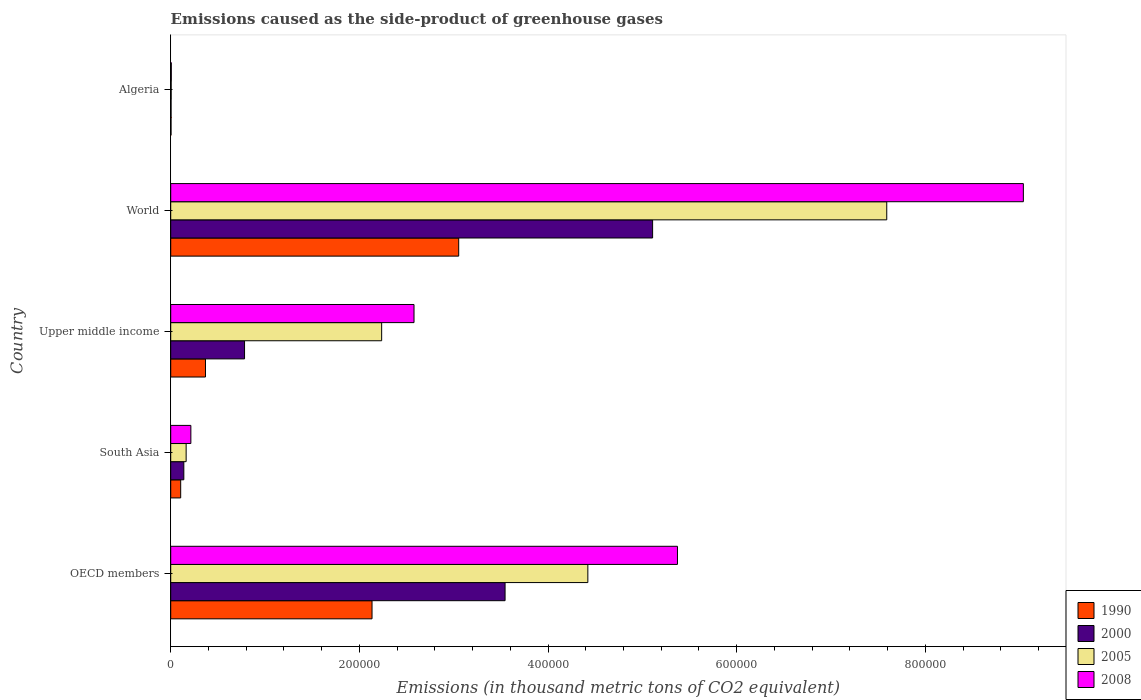How many different coloured bars are there?
Ensure brevity in your answer.  4. How many groups of bars are there?
Give a very brief answer. 5. Are the number of bars per tick equal to the number of legend labels?
Your answer should be compact. Yes. How many bars are there on the 3rd tick from the top?
Provide a short and direct response. 4. How many bars are there on the 2nd tick from the bottom?
Keep it short and to the point. 4. In how many cases, is the number of bars for a given country not equal to the number of legend labels?
Make the answer very short. 0. What is the emissions caused as the side-product of greenhouse gases in 1990 in World?
Keep it short and to the point. 3.05e+05. Across all countries, what is the maximum emissions caused as the side-product of greenhouse gases in 1990?
Offer a very short reply. 3.05e+05. Across all countries, what is the minimum emissions caused as the side-product of greenhouse gases in 2005?
Ensure brevity in your answer.  487.4. In which country was the emissions caused as the side-product of greenhouse gases in 1990 minimum?
Keep it short and to the point. Algeria. What is the total emissions caused as the side-product of greenhouse gases in 2005 in the graph?
Your answer should be very brief. 1.44e+06. What is the difference between the emissions caused as the side-product of greenhouse gases in 2008 in Algeria and that in Upper middle income?
Keep it short and to the point. -2.57e+05. What is the difference between the emissions caused as the side-product of greenhouse gases in 1990 in South Asia and the emissions caused as the side-product of greenhouse gases in 2008 in Upper middle income?
Your answer should be compact. -2.47e+05. What is the average emissions caused as the side-product of greenhouse gases in 1990 per country?
Offer a very short reply. 1.13e+05. What is the difference between the emissions caused as the side-product of greenhouse gases in 2000 and emissions caused as the side-product of greenhouse gases in 2008 in South Asia?
Offer a very short reply. -7460.6. In how many countries, is the emissions caused as the side-product of greenhouse gases in 2000 greater than 840000 thousand metric tons?
Offer a very short reply. 0. What is the ratio of the emissions caused as the side-product of greenhouse gases in 2000 in South Asia to that in Upper middle income?
Your answer should be very brief. 0.18. Is the difference between the emissions caused as the side-product of greenhouse gases in 2000 in OECD members and World greater than the difference between the emissions caused as the side-product of greenhouse gases in 2008 in OECD members and World?
Your answer should be very brief. Yes. What is the difference between the highest and the second highest emissions caused as the side-product of greenhouse gases in 2000?
Your answer should be very brief. 1.56e+05. What is the difference between the highest and the lowest emissions caused as the side-product of greenhouse gases in 2000?
Your answer should be compact. 5.11e+05. What does the 2nd bar from the bottom in South Asia represents?
Offer a terse response. 2000. Is it the case that in every country, the sum of the emissions caused as the side-product of greenhouse gases in 1990 and emissions caused as the side-product of greenhouse gases in 2005 is greater than the emissions caused as the side-product of greenhouse gases in 2000?
Make the answer very short. Yes. How many bars are there?
Provide a succinct answer. 20. How many countries are there in the graph?
Offer a very short reply. 5. What is the difference between two consecutive major ticks on the X-axis?
Offer a very short reply. 2.00e+05. Are the values on the major ticks of X-axis written in scientific E-notation?
Provide a succinct answer. No. Does the graph contain grids?
Provide a short and direct response. No. Where does the legend appear in the graph?
Your response must be concise. Bottom right. What is the title of the graph?
Your answer should be very brief. Emissions caused as the side-product of greenhouse gases. Does "1968" appear as one of the legend labels in the graph?
Offer a very short reply. No. What is the label or title of the X-axis?
Offer a terse response. Emissions (in thousand metric tons of CO2 equivalent). What is the Emissions (in thousand metric tons of CO2 equivalent) in 1990 in OECD members?
Ensure brevity in your answer.  2.13e+05. What is the Emissions (in thousand metric tons of CO2 equivalent) of 2000 in OECD members?
Your response must be concise. 3.54e+05. What is the Emissions (in thousand metric tons of CO2 equivalent) of 2005 in OECD members?
Your answer should be compact. 4.42e+05. What is the Emissions (in thousand metric tons of CO2 equivalent) in 2008 in OECD members?
Your response must be concise. 5.37e+05. What is the Emissions (in thousand metric tons of CO2 equivalent) of 1990 in South Asia?
Your answer should be compact. 1.06e+04. What is the Emissions (in thousand metric tons of CO2 equivalent) of 2000 in South Asia?
Provide a short and direct response. 1.39e+04. What is the Emissions (in thousand metric tons of CO2 equivalent) in 2005 in South Asia?
Give a very brief answer. 1.64e+04. What is the Emissions (in thousand metric tons of CO2 equivalent) of 2008 in South Asia?
Make the answer very short. 2.14e+04. What is the Emissions (in thousand metric tons of CO2 equivalent) in 1990 in Upper middle income?
Ensure brevity in your answer.  3.69e+04. What is the Emissions (in thousand metric tons of CO2 equivalent) in 2000 in Upper middle income?
Your answer should be very brief. 7.83e+04. What is the Emissions (in thousand metric tons of CO2 equivalent) in 2005 in Upper middle income?
Your answer should be compact. 2.24e+05. What is the Emissions (in thousand metric tons of CO2 equivalent) of 2008 in Upper middle income?
Ensure brevity in your answer.  2.58e+05. What is the Emissions (in thousand metric tons of CO2 equivalent) in 1990 in World?
Ensure brevity in your answer.  3.05e+05. What is the Emissions (in thousand metric tons of CO2 equivalent) in 2000 in World?
Make the answer very short. 5.11e+05. What is the Emissions (in thousand metric tons of CO2 equivalent) of 2005 in World?
Provide a short and direct response. 7.59e+05. What is the Emissions (in thousand metric tons of CO2 equivalent) in 2008 in World?
Ensure brevity in your answer.  9.04e+05. What is the Emissions (in thousand metric tons of CO2 equivalent) of 1990 in Algeria?
Your answer should be compact. 326. What is the Emissions (in thousand metric tons of CO2 equivalent) of 2000 in Algeria?
Offer a very short reply. 371.9. What is the Emissions (in thousand metric tons of CO2 equivalent) of 2005 in Algeria?
Your answer should be compact. 487.4. What is the Emissions (in thousand metric tons of CO2 equivalent) of 2008 in Algeria?
Your answer should be compact. 613.9. Across all countries, what is the maximum Emissions (in thousand metric tons of CO2 equivalent) of 1990?
Offer a terse response. 3.05e+05. Across all countries, what is the maximum Emissions (in thousand metric tons of CO2 equivalent) of 2000?
Give a very brief answer. 5.11e+05. Across all countries, what is the maximum Emissions (in thousand metric tons of CO2 equivalent) in 2005?
Make the answer very short. 7.59e+05. Across all countries, what is the maximum Emissions (in thousand metric tons of CO2 equivalent) in 2008?
Ensure brevity in your answer.  9.04e+05. Across all countries, what is the minimum Emissions (in thousand metric tons of CO2 equivalent) in 1990?
Your response must be concise. 326. Across all countries, what is the minimum Emissions (in thousand metric tons of CO2 equivalent) of 2000?
Give a very brief answer. 371.9. Across all countries, what is the minimum Emissions (in thousand metric tons of CO2 equivalent) in 2005?
Keep it short and to the point. 487.4. Across all countries, what is the minimum Emissions (in thousand metric tons of CO2 equivalent) in 2008?
Make the answer very short. 613.9. What is the total Emissions (in thousand metric tons of CO2 equivalent) in 1990 in the graph?
Your answer should be very brief. 5.67e+05. What is the total Emissions (in thousand metric tons of CO2 equivalent) of 2000 in the graph?
Make the answer very short. 9.58e+05. What is the total Emissions (in thousand metric tons of CO2 equivalent) of 2005 in the graph?
Offer a terse response. 1.44e+06. What is the total Emissions (in thousand metric tons of CO2 equivalent) in 2008 in the graph?
Your answer should be very brief. 1.72e+06. What is the difference between the Emissions (in thousand metric tons of CO2 equivalent) in 1990 in OECD members and that in South Asia?
Provide a succinct answer. 2.03e+05. What is the difference between the Emissions (in thousand metric tons of CO2 equivalent) of 2000 in OECD members and that in South Asia?
Give a very brief answer. 3.41e+05. What is the difference between the Emissions (in thousand metric tons of CO2 equivalent) of 2005 in OECD members and that in South Asia?
Give a very brief answer. 4.26e+05. What is the difference between the Emissions (in thousand metric tons of CO2 equivalent) in 2008 in OECD members and that in South Asia?
Keep it short and to the point. 5.16e+05. What is the difference between the Emissions (in thousand metric tons of CO2 equivalent) in 1990 in OECD members and that in Upper middle income?
Offer a terse response. 1.77e+05. What is the difference between the Emissions (in thousand metric tons of CO2 equivalent) of 2000 in OECD members and that in Upper middle income?
Your answer should be compact. 2.76e+05. What is the difference between the Emissions (in thousand metric tons of CO2 equivalent) in 2005 in OECD members and that in Upper middle income?
Offer a very short reply. 2.19e+05. What is the difference between the Emissions (in thousand metric tons of CO2 equivalent) of 2008 in OECD members and that in Upper middle income?
Ensure brevity in your answer.  2.79e+05. What is the difference between the Emissions (in thousand metric tons of CO2 equivalent) of 1990 in OECD members and that in World?
Give a very brief answer. -9.19e+04. What is the difference between the Emissions (in thousand metric tons of CO2 equivalent) of 2000 in OECD members and that in World?
Your answer should be very brief. -1.56e+05. What is the difference between the Emissions (in thousand metric tons of CO2 equivalent) of 2005 in OECD members and that in World?
Provide a succinct answer. -3.17e+05. What is the difference between the Emissions (in thousand metric tons of CO2 equivalent) of 2008 in OECD members and that in World?
Offer a very short reply. -3.67e+05. What is the difference between the Emissions (in thousand metric tons of CO2 equivalent) in 1990 in OECD members and that in Algeria?
Your answer should be very brief. 2.13e+05. What is the difference between the Emissions (in thousand metric tons of CO2 equivalent) in 2000 in OECD members and that in Algeria?
Offer a terse response. 3.54e+05. What is the difference between the Emissions (in thousand metric tons of CO2 equivalent) in 2005 in OECD members and that in Algeria?
Your response must be concise. 4.42e+05. What is the difference between the Emissions (in thousand metric tons of CO2 equivalent) in 2008 in OECD members and that in Algeria?
Give a very brief answer. 5.37e+05. What is the difference between the Emissions (in thousand metric tons of CO2 equivalent) of 1990 in South Asia and that in Upper middle income?
Provide a succinct answer. -2.63e+04. What is the difference between the Emissions (in thousand metric tons of CO2 equivalent) in 2000 in South Asia and that in Upper middle income?
Offer a terse response. -6.44e+04. What is the difference between the Emissions (in thousand metric tons of CO2 equivalent) of 2005 in South Asia and that in Upper middle income?
Keep it short and to the point. -2.07e+05. What is the difference between the Emissions (in thousand metric tons of CO2 equivalent) in 2008 in South Asia and that in Upper middle income?
Ensure brevity in your answer.  -2.37e+05. What is the difference between the Emissions (in thousand metric tons of CO2 equivalent) in 1990 in South Asia and that in World?
Make the answer very short. -2.95e+05. What is the difference between the Emissions (in thousand metric tons of CO2 equivalent) in 2000 in South Asia and that in World?
Your answer should be compact. -4.97e+05. What is the difference between the Emissions (in thousand metric tons of CO2 equivalent) of 2005 in South Asia and that in World?
Offer a terse response. -7.43e+05. What is the difference between the Emissions (in thousand metric tons of CO2 equivalent) in 2008 in South Asia and that in World?
Give a very brief answer. -8.83e+05. What is the difference between the Emissions (in thousand metric tons of CO2 equivalent) of 1990 in South Asia and that in Algeria?
Offer a terse response. 1.02e+04. What is the difference between the Emissions (in thousand metric tons of CO2 equivalent) in 2000 in South Asia and that in Algeria?
Offer a terse response. 1.35e+04. What is the difference between the Emissions (in thousand metric tons of CO2 equivalent) of 2005 in South Asia and that in Algeria?
Ensure brevity in your answer.  1.59e+04. What is the difference between the Emissions (in thousand metric tons of CO2 equivalent) in 2008 in South Asia and that in Algeria?
Give a very brief answer. 2.07e+04. What is the difference between the Emissions (in thousand metric tons of CO2 equivalent) of 1990 in Upper middle income and that in World?
Your response must be concise. -2.68e+05. What is the difference between the Emissions (in thousand metric tons of CO2 equivalent) of 2000 in Upper middle income and that in World?
Offer a terse response. -4.33e+05. What is the difference between the Emissions (in thousand metric tons of CO2 equivalent) of 2005 in Upper middle income and that in World?
Provide a short and direct response. -5.36e+05. What is the difference between the Emissions (in thousand metric tons of CO2 equivalent) of 2008 in Upper middle income and that in World?
Give a very brief answer. -6.46e+05. What is the difference between the Emissions (in thousand metric tons of CO2 equivalent) in 1990 in Upper middle income and that in Algeria?
Provide a short and direct response. 3.65e+04. What is the difference between the Emissions (in thousand metric tons of CO2 equivalent) of 2000 in Upper middle income and that in Algeria?
Ensure brevity in your answer.  7.79e+04. What is the difference between the Emissions (in thousand metric tons of CO2 equivalent) of 2005 in Upper middle income and that in Algeria?
Provide a succinct answer. 2.23e+05. What is the difference between the Emissions (in thousand metric tons of CO2 equivalent) in 2008 in Upper middle income and that in Algeria?
Provide a short and direct response. 2.57e+05. What is the difference between the Emissions (in thousand metric tons of CO2 equivalent) of 1990 in World and that in Algeria?
Give a very brief answer. 3.05e+05. What is the difference between the Emissions (in thousand metric tons of CO2 equivalent) in 2000 in World and that in Algeria?
Provide a succinct answer. 5.11e+05. What is the difference between the Emissions (in thousand metric tons of CO2 equivalent) of 2005 in World and that in Algeria?
Ensure brevity in your answer.  7.59e+05. What is the difference between the Emissions (in thousand metric tons of CO2 equivalent) in 2008 in World and that in Algeria?
Give a very brief answer. 9.03e+05. What is the difference between the Emissions (in thousand metric tons of CO2 equivalent) in 1990 in OECD members and the Emissions (in thousand metric tons of CO2 equivalent) in 2000 in South Asia?
Offer a very short reply. 2.00e+05. What is the difference between the Emissions (in thousand metric tons of CO2 equivalent) of 1990 in OECD members and the Emissions (in thousand metric tons of CO2 equivalent) of 2005 in South Asia?
Offer a very short reply. 1.97e+05. What is the difference between the Emissions (in thousand metric tons of CO2 equivalent) of 1990 in OECD members and the Emissions (in thousand metric tons of CO2 equivalent) of 2008 in South Asia?
Offer a very short reply. 1.92e+05. What is the difference between the Emissions (in thousand metric tons of CO2 equivalent) of 2000 in OECD members and the Emissions (in thousand metric tons of CO2 equivalent) of 2005 in South Asia?
Provide a short and direct response. 3.38e+05. What is the difference between the Emissions (in thousand metric tons of CO2 equivalent) of 2000 in OECD members and the Emissions (in thousand metric tons of CO2 equivalent) of 2008 in South Asia?
Your response must be concise. 3.33e+05. What is the difference between the Emissions (in thousand metric tons of CO2 equivalent) of 2005 in OECD members and the Emissions (in thousand metric tons of CO2 equivalent) of 2008 in South Asia?
Ensure brevity in your answer.  4.21e+05. What is the difference between the Emissions (in thousand metric tons of CO2 equivalent) of 1990 in OECD members and the Emissions (in thousand metric tons of CO2 equivalent) of 2000 in Upper middle income?
Keep it short and to the point. 1.35e+05. What is the difference between the Emissions (in thousand metric tons of CO2 equivalent) in 1990 in OECD members and the Emissions (in thousand metric tons of CO2 equivalent) in 2005 in Upper middle income?
Make the answer very short. -1.02e+04. What is the difference between the Emissions (in thousand metric tons of CO2 equivalent) of 1990 in OECD members and the Emissions (in thousand metric tons of CO2 equivalent) of 2008 in Upper middle income?
Your answer should be very brief. -4.45e+04. What is the difference between the Emissions (in thousand metric tons of CO2 equivalent) of 2000 in OECD members and the Emissions (in thousand metric tons of CO2 equivalent) of 2005 in Upper middle income?
Your answer should be very brief. 1.31e+05. What is the difference between the Emissions (in thousand metric tons of CO2 equivalent) in 2000 in OECD members and the Emissions (in thousand metric tons of CO2 equivalent) in 2008 in Upper middle income?
Provide a succinct answer. 9.65e+04. What is the difference between the Emissions (in thousand metric tons of CO2 equivalent) of 2005 in OECD members and the Emissions (in thousand metric tons of CO2 equivalent) of 2008 in Upper middle income?
Your answer should be very brief. 1.84e+05. What is the difference between the Emissions (in thousand metric tons of CO2 equivalent) in 1990 in OECD members and the Emissions (in thousand metric tons of CO2 equivalent) in 2000 in World?
Keep it short and to the point. -2.97e+05. What is the difference between the Emissions (in thousand metric tons of CO2 equivalent) in 1990 in OECD members and the Emissions (in thousand metric tons of CO2 equivalent) in 2005 in World?
Make the answer very short. -5.46e+05. What is the difference between the Emissions (in thousand metric tons of CO2 equivalent) of 1990 in OECD members and the Emissions (in thousand metric tons of CO2 equivalent) of 2008 in World?
Make the answer very short. -6.91e+05. What is the difference between the Emissions (in thousand metric tons of CO2 equivalent) of 2000 in OECD members and the Emissions (in thousand metric tons of CO2 equivalent) of 2005 in World?
Your answer should be very brief. -4.05e+05. What is the difference between the Emissions (in thousand metric tons of CO2 equivalent) of 2000 in OECD members and the Emissions (in thousand metric tons of CO2 equivalent) of 2008 in World?
Your answer should be compact. -5.49e+05. What is the difference between the Emissions (in thousand metric tons of CO2 equivalent) in 2005 in OECD members and the Emissions (in thousand metric tons of CO2 equivalent) in 2008 in World?
Offer a very short reply. -4.62e+05. What is the difference between the Emissions (in thousand metric tons of CO2 equivalent) in 1990 in OECD members and the Emissions (in thousand metric tons of CO2 equivalent) in 2000 in Algeria?
Offer a very short reply. 2.13e+05. What is the difference between the Emissions (in thousand metric tons of CO2 equivalent) of 1990 in OECD members and the Emissions (in thousand metric tons of CO2 equivalent) of 2005 in Algeria?
Give a very brief answer. 2.13e+05. What is the difference between the Emissions (in thousand metric tons of CO2 equivalent) of 1990 in OECD members and the Emissions (in thousand metric tons of CO2 equivalent) of 2008 in Algeria?
Keep it short and to the point. 2.13e+05. What is the difference between the Emissions (in thousand metric tons of CO2 equivalent) of 2000 in OECD members and the Emissions (in thousand metric tons of CO2 equivalent) of 2005 in Algeria?
Provide a short and direct response. 3.54e+05. What is the difference between the Emissions (in thousand metric tons of CO2 equivalent) of 2000 in OECD members and the Emissions (in thousand metric tons of CO2 equivalent) of 2008 in Algeria?
Make the answer very short. 3.54e+05. What is the difference between the Emissions (in thousand metric tons of CO2 equivalent) in 2005 in OECD members and the Emissions (in thousand metric tons of CO2 equivalent) in 2008 in Algeria?
Keep it short and to the point. 4.42e+05. What is the difference between the Emissions (in thousand metric tons of CO2 equivalent) in 1990 in South Asia and the Emissions (in thousand metric tons of CO2 equivalent) in 2000 in Upper middle income?
Provide a short and direct response. -6.77e+04. What is the difference between the Emissions (in thousand metric tons of CO2 equivalent) in 1990 in South Asia and the Emissions (in thousand metric tons of CO2 equivalent) in 2005 in Upper middle income?
Offer a terse response. -2.13e+05. What is the difference between the Emissions (in thousand metric tons of CO2 equivalent) in 1990 in South Asia and the Emissions (in thousand metric tons of CO2 equivalent) in 2008 in Upper middle income?
Offer a very short reply. -2.47e+05. What is the difference between the Emissions (in thousand metric tons of CO2 equivalent) in 2000 in South Asia and the Emissions (in thousand metric tons of CO2 equivalent) in 2005 in Upper middle income?
Provide a succinct answer. -2.10e+05. What is the difference between the Emissions (in thousand metric tons of CO2 equivalent) in 2000 in South Asia and the Emissions (in thousand metric tons of CO2 equivalent) in 2008 in Upper middle income?
Offer a terse response. -2.44e+05. What is the difference between the Emissions (in thousand metric tons of CO2 equivalent) of 2005 in South Asia and the Emissions (in thousand metric tons of CO2 equivalent) of 2008 in Upper middle income?
Your response must be concise. -2.42e+05. What is the difference between the Emissions (in thousand metric tons of CO2 equivalent) in 1990 in South Asia and the Emissions (in thousand metric tons of CO2 equivalent) in 2000 in World?
Keep it short and to the point. -5.00e+05. What is the difference between the Emissions (in thousand metric tons of CO2 equivalent) of 1990 in South Asia and the Emissions (in thousand metric tons of CO2 equivalent) of 2005 in World?
Offer a very short reply. -7.49e+05. What is the difference between the Emissions (in thousand metric tons of CO2 equivalent) in 1990 in South Asia and the Emissions (in thousand metric tons of CO2 equivalent) in 2008 in World?
Offer a very short reply. -8.93e+05. What is the difference between the Emissions (in thousand metric tons of CO2 equivalent) of 2000 in South Asia and the Emissions (in thousand metric tons of CO2 equivalent) of 2005 in World?
Offer a very short reply. -7.45e+05. What is the difference between the Emissions (in thousand metric tons of CO2 equivalent) in 2000 in South Asia and the Emissions (in thousand metric tons of CO2 equivalent) in 2008 in World?
Offer a very short reply. -8.90e+05. What is the difference between the Emissions (in thousand metric tons of CO2 equivalent) of 2005 in South Asia and the Emissions (in thousand metric tons of CO2 equivalent) of 2008 in World?
Ensure brevity in your answer.  -8.88e+05. What is the difference between the Emissions (in thousand metric tons of CO2 equivalent) of 1990 in South Asia and the Emissions (in thousand metric tons of CO2 equivalent) of 2000 in Algeria?
Offer a very short reply. 1.02e+04. What is the difference between the Emissions (in thousand metric tons of CO2 equivalent) in 1990 in South Asia and the Emissions (in thousand metric tons of CO2 equivalent) in 2005 in Algeria?
Give a very brief answer. 1.01e+04. What is the difference between the Emissions (in thousand metric tons of CO2 equivalent) of 1990 in South Asia and the Emissions (in thousand metric tons of CO2 equivalent) of 2008 in Algeria?
Offer a very short reply. 9958.7. What is the difference between the Emissions (in thousand metric tons of CO2 equivalent) in 2000 in South Asia and the Emissions (in thousand metric tons of CO2 equivalent) in 2005 in Algeria?
Offer a terse response. 1.34e+04. What is the difference between the Emissions (in thousand metric tons of CO2 equivalent) of 2000 in South Asia and the Emissions (in thousand metric tons of CO2 equivalent) of 2008 in Algeria?
Provide a succinct answer. 1.33e+04. What is the difference between the Emissions (in thousand metric tons of CO2 equivalent) in 2005 in South Asia and the Emissions (in thousand metric tons of CO2 equivalent) in 2008 in Algeria?
Provide a succinct answer. 1.57e+04. What is the difference between the Emissions (in thousand metric tons of CO2 equivalent) of 1990 in Upper middle income and the Emissions (in thousand metric tons of CO2 equivalent) of 2000 in World?
Provide a succinct answer. -4.74e+05. What is the difference between the Emissions (in thousand metric tons of CO2 equivalent) of 1990 in Upper middle income and the Emissions (in thousand metric tons of CO2 equivalent) of 2005 in World?
Give a very brief answer. -7.22e+05. What is the difference between the Emissions (in thousand metric tons of CO2 equivalent) in 1990 in Upper middle income and the Emissions (in thousand metric tons of CO2 equivalent) in 2008 in World?
Keep it short and to the point. -8.67e+05. What is the difference between the Emissions (in thousand metric tons of CO2 equivalent) in 2000 in Upper middle income and the Emissions (in thousand metric tons of CO2 equivalent) in 2005 in World?
Give a very brief answer. -6.81e+05. What is the difference between the Emissions (in thousand metric tons of CO2 equivalent) of 2000 in Upper middle income and the Emissions (in thousand metric tons of CO2 equivalent) of 2008 in World?
Your answer should be compact. -8.26e+05. What is the difference between the Emissions (in thousand metric tons of CO2 equivalent) in 2005 in Upper middle income and the Emissions (in thousand metric tons of CO2 equivalent) in 2008 in World?
Offer a very short reply. -6.80e+05. What is the difference between the Emissions (in thousand metric tons of CO2 equivalent) in 1990 in Upper middle income and the Emissions (in thousand metric tons of CO2 equivalent) in 2000 in Algeria?
Provide a succinct answer. 3.65e+04. What is the difference between the Emissions (in thousand metric tons of CO2 equivalent) of 1990 in Upper middle income and the Emissions (in thousand metric tons of CO2 equivalent) of 2005 in Algeria?
Ensure brevity in your answer.  3.64e+04. What is the difference between the Emissions (in thousand metric tons of CO2 equivalent) of 1990 in Upper middle income and the Emissions (in thousand metric tons of CO2 equivalent) of 2008 in Algeria?
Your answer should be compact. 3.63e+04. What is the difference between the Emissions (in thousand metric tons of CO2 equivalent) of 2000 in Upper middle income and the Emissions (in thousand metric tons of CO2 equivalent) of 2005 in Algeria?
Your response must be concise. 7.78e+04. What is the difference between the Emissions (in thousand metric tons of CO2 equivalent) of 2000 in Upper middle income and the Emissions (in thousand metric tons of CO2 equivalent) of 2008 in Algeria?
Provide a succinct answer. 7.77e+04. What is the difference between the Emissions (in thousand metric tons of CO2 equivalent) in 2005 in Upper middle income and the Emissions (in thousand metric tons of CO2 equivalent) in 2008 in Algeria?
Your answer should be compact. 2.23e+05. What is the difference between the Emissions (in thousand metric tons of CO2 equivalent) in 1990 in World and the Emissions (in thousand metric tons of CO2 equivalent) in 2000 in Algeria?
Provide a succinct answer. 3.05e+05. What is the difference between the Emissions (in thousand metric tons of CO2 equivalent) in 1990 in World and the Emissions (in thousand metric tons of CO2 equivalent) in 2005 in Algeria?
Your answer should be compact. 3.05e+05. What is the difference between the Emissions (in thousand metric tons of CO2 equivalent) of 1990 in World and the Emissions (in thousand metric tons of CO2 equivalent) of 2008 in Algeria?
Make the answer very short. 3.05e+05. What is the difference between the Emissions (in thousand metric tons of CO2 equivalent) in 2000 in World and the Emissions (in thousand metric tons of CO2 equivalent) in 2005 in Algeria?
Ensure brevity in your answer.  5.10e+05. What is the difference between the Emissions (in thousand metric tons of CO2 equivalent) of 2000 in World and the Emissions (in thousand metric tons of CO2 equivalent) of 2008 in Algeria?
Give a very brief answer. 5.10e+05. What is the difference between the Emissions (in thousand metric tons of CO2 equivalent) in 2005 in World and the Emissions (in thousand metric tons of CO2 equivalent) in 2008 in Algeria?
Make the answer very short. 7.59e+05. What is the average Emissions (in thousand metric tons of CO2 equivalent) of 1990 per country?
Provide a short and direct response. 1.13e+05. What is the average Emissions (in thousand metric tons of CO2 equivalent) of 2000 per country?
Provide a short and direct response. 1.92e+05. What is the average Emissions (in thousand metric tons of CO2 equivalent) of 2005 per country?
Offer a terse response. 2.88e+05. What is the average Emissions (in thousand metric tons of CO2 equivalent) of 2008 per country?
Provide a short and direct response. 3.44e+05. What is the difference between the Emissions (in thousand metric tons of CO2 equivalent) of 1990 and Emissions (in thousand metric tons of CO2 equivalent) of 2000 in OECD members?
Offer a terse response. -1.41e+05. What is the difference between the Emissions (in thousand metric tons of CO2 equivalent) of 1990 and Emissions (in thousand metric tons of CO2 equivalent) of 2005 in OECD members?
Provide a short and direct response. -2.29e+05. What is the difference between the Emissions (in thousand metric tons of CO2 equivalent) in 1990 and Emissions (in thousand metric tons of CO2 equivalent) in 2008 in OECD members?
Make the answer very short. -3.24e+05. What is the difference between the Emissions (in thousand metric tons of CO2 equivalent) in 2000 and Emissions (in thousand metric tons of CO2 equivalent) in 2005 in OECD members?
Your response must be concise. -8.78e+04. What is the difference between the Emissions (in thousand metric tons of CO2 equivalent) in 2000 and Emissions (in thousand metric tons of CO2 equivalent) in 2008 in OECD members?
Your answer should be compact. -1.83e+05. What is the difference between the Emissions (in thousand metric tons of CO2 equivalent) in 2005 and Emissions (in thousand metric tons of CO2 equivalent) in 2008 in OECD members?
Ensure brevity in your answer.  -9.50e+04. What is the difference between the Emissions (in thousand metric tons of CO2 equivalent) of 1990 and Emissions (in thousand metric tons of CO2 equivalent) of 2000 in South Asia?
Offer a terse response. -3325.3. What is the difference between the Emissions (in thousand metric tons of CO2 equivalent) in 1990 and Emissions (in thousand metric tons of CO2 equivalent) in 2005 in South Asia?
Offer a terse response. -5786.5. What is the difference between the Emissions (in thousand metric tons of CO2 equivalent) in 1990 and Emissions (in thousand metric tons of CO2 equivalent) in 2008 in South Asia?
Your response must be concise. -1.08e+04. What is the difference between the Emissions (in thousand metric tons of CO2 equivalent) in 2000 and Emissions (in thousand metric tons of CO2 equivalent) in 2005 in South Asia?
Offer a terse response. -2461.2. What is the difference between the Emissions (in thousand metric tons of CO2 equivalent) of 2000 and Emissions (in thousand metric tons of CO2 equivalent) of 2008 in South Asia?
Give a very brief answer. -7460.6. What is the difference between the Emissions (in thousand metric tons of CO2 equivalent) in 2005 and Emissions (in thousand metric tons of CO2 equivalent) in 2008 in South Asia?
Offer a very short reply. -4999.4. What is the difference between the Emissions (in thousand metric tons of CO2 equivalent) in 1990 and Emissions (in thousand metric tons of CO2 equivalent) in 2000 in Upper middle income?
Provide a short and direct response. -4.14e+04. What is the difference between the Emissions (in thousand metric tons of CO2 equivalent) in 1990 and Emissions (in thousand metric tons of CO2 equivalent) in 2005 in Upper middle income?
Offer a terse response. -1.87e+05. What is the difference between the Emissions (in thousand metric tons of CO2 equivalent) of 1990 and Emissions (in thousand metric tons of CO2 equivalent) of 2008 in Upper middle income?
Provide a short and direct response. -2.21e+05. What is the difference between the Emissions (in thousand metric tons of CO2 equivalent) of 2000 and Emissions (in thousand metric tons of CO2 equivalent) of 2005 in Upper middle income?
Offer a terse response. -1.45e+05. What is the difference between the Emissions (in thousand metric tons of CO2 equivalent) in 2000 and Emissions (in thousand metric tons of CO2 equivalent) in 2008 in Upper middle income?
Keep it short and to the point. -1.80e+05. What is the difference between the Emissions (in thousand metric tons of CO2 equivalent) in 2005 and Emissions (in thousand metric tons of CO2 equivalent) in 2008 in Upper middle income?
Offer a terse response. -3.43e+04. What is the difference between the Emissions (in thousand metric tons of CO2 equivalent) in 1990 and Emissions (in thousand metric tons of CO2 equivalent) in 2000 in World?
Keep it short and to the point. -2.06e+05. What is the difference between the Emissions (in thousand metric tons of CO2 equivalent) in 1990 and Emissions (in thousand metric tons of CO2 equivalent) in 2005 in World?
Provide a short and direct response. -4.54e+05. What is the difference between the Emissions (in thousand metric tons of CO2 equivalent) in 1990 and Emissions (in thousand metric tons of CO2 equivalent) in 2008 in World?
Provide a succinct answer. -5.99e+05. What is the difference between the Emissions (in thousand metric tons of CO2 equivalent) in 2000 and Emissions (in thousand metric tons of CO2 equivalent) in 2005 in World?
Your response must be concise. -2.48e+05. What is the difference between the Emissions (in thousand metric tons of CO2 equivalent) in 2000 and Emissions (in thousand metric tons of CO2 equivalent) in 2008 in World?
Offer a terse response. -3.93e+05. What is the difference between the Emissions (in thousand metric tons of CO2 equivalent) in 2005 and Emissions (in thousand metric tons of CO2 equivalent) in 2008 in World?
Your answer should be very brief. -1.45e+05. What is the difference between the Emissions (in thousand metric tons of CO2 equivalent) of 1990 and Emissions (in thousand metric tons of CO2 equivalent) of 2000 in Algeria?
Keep it short and to the point. -45.9. What is the difference between the Emissions (in thousand metric tons of CO2 equivalent) in 1990 and Emissions (in thousand metric tons of CO2 equivalent) in 2005 in Algeria?
Keep it short and to the point. -161.4. What is the difference between the Emissions (in thousand metric tons of CO2 equivalent) in 1990 and Emissions (in thousand metric tons of CO2 equivalent) in 2008 in Algeria?
Keep it short and to the point. -287.9. What is the difference between the Emissions (in thousand metric tons of CO2 equivalent) in 2000 and Emissions (in thousand metric tons of CO2 equivalent) in 2005 in Algeria?
Provide a short and direct response. -115.5. What is the difference between the Emissions (in thousand metric tons of CO2 equivalent) in 2000 and Emissions (in thousand metric tons of CO2 equivalent) in 2008 in Algeria?
Your response must be concise. -242. What is the difference between the Emissions (in thousand metric tons of CO2 equivalent) in 2005 and Emissions (in thousand metric tons of CO2 equivalent) in 2008 in Algeria?
Provide a succinct answer. -126.5. What is the ratio of the Emissions (in thousand metric tons of CO2 equivalent) in 1990 in OECD members to that in South Asia?
Your response must be concise. 20.19. What is the ratio of the Emissions (in thousand metric tons of CO2 equivalent) of 2000 in OECD members to that in South Asia?
Provide a succinct answer. 25.51. What is the ratio of the Emissions (in thousand metric tons of CO2 equivalent) in 2005 in OECD members to that in South Asia?
Your answer should be very brief. 27.03. What is the ratio of the Emissions (in thousand metric tons of CO2 equivalent) in 2008 in OECD members to that in South Asia?
Provide a succinct answer. 25.15. What is the ratio of the Emissions (in thousand metric tons of CO2 equivalent) of 1990 in OECD members to that in Upper middle income?
Ensure brevity in your answer.  5.79. What is the ratio of the Emissions (in thousand metric tons of CO2 equivalent) of 2000 in OECD members to that in Upper middle income?
Offer a terse response. 4.53. What is the ratio of the Emissions (in thousand metric tons of CO2 equivalent) in 2005 in OECD members to that in Upper middle income?
Your response must be concise. 1.98. What is the ratio of the Emissions (in thousand metric tons of CO2 equivalent) of 2008 in OECD members to that in Upper middle income?
Provide a succinct answer. 2.08. What is the ratio of the Emissions (in thousand metric tons of CO2 equivalent) of 1990 in OECD members to that in World?
Give a very brief answer. 0.7. What is the ratio of the Emissions (in thousand metric tons of CO2 equivalent) in 2000 in OECD members to that in World?
Provide a succinct answer. 0.69. What is the ratio of the Emissions (in thousand metric tons of CO2 equivalent) in 2005 in OECD members to that in World?
Your response must be concise. 0.58. What is the ratio of the Emissions (in thousand metric tons of CO2 equivalent) in 2008 in OECD members to that in World?
Give a very brief answer. 0.59. What is the ratio of the Emissions (in thousand metric tons of CO2 equivalent) of 1990 in OECD members to that in Algeria?
Your response must be concise. 654.71. What is the ratio of the Emissions (in thousand metric tons of CO2 equivalent) in 2000 in OECD members to that in Algeria?
Your answer should be compact. 953.18. What is the ratio of the Emissions (in thousand metric tons of CO2 equivalent) in 2005 in OECD members to that in Algeria?
Keep it short and to the point. 907.34. What is the ratio of the Emissions (in thousand metric tons of CO2 equivalent) in 2008 in OECD members to that in Algeria?
Offer a terse response. 875.16. What is the ratio of the Emissions (in thousand metric tons of CO2 equivalent) in 1990 in South Asia to that in Upper middle income?
Provide a succinct answer. 0.29. What is the ratio of the Emissions (in thousand metric tons of CO2 equivalent) of 2000 in South Asia to that in Upper middle income?
Provide a succinct answer. 0.18. What is the ratio of the Emissions (in thousand metric tons of CO2 equivalent) in 2005 in South Asia to that in Upper middle income?
Provide a short and direct response. 0.07. What is the ratio of the Emissions (in thousand metric tons of CO2 equivalent) of 2008 in South Asia to that in Upper middle income?
Your answer should be compact. 0.08. What is the ratio of the Emissions (in thousand metric tons of CO2 equivalent) of 1990 in South Asia to that in World?
Your answer should be very brief. 0.03. What is the ratio of the Emissions (in thousand metric tons of CO2 equivalent) of 2000 in South Asia to that in World?
Make the answer very short. 0.03. What is the ratio of the Emissions (in thousand metric tons of CO2 equivalent) in 2005 in South Asia to that in World?
Your answer should be very brief. 0.02. What is the ratio of the Emissions (in thousand metric tons of CO2 equivalent) of 2008 in South Asia to that in World?
Your response must be concise. 0.02. What is the ratio of the Emissions (in thousand metric tons of CO2 equivalent) of 1990 in South Asia to that in Algeria?
Provide a short and direct response. 32.43. What is the ratio of the Emissions (in thousand metric tons of CO2 equivalent) of 2000 in South Asia to that in Algeria?
Your answer should be very brief. 37.37. What is the ratio of the Emissions (in thousand metric tons of CO2 equivalent) of 2005 in South Asia to that in Algeria?
Offer a very short reply. 33.56. What is the ratio of the Emissions (in thousand metric tons of CO2 equivalent) in 2008 in South Asia to that in Algeria?
Offer a very short reply. 34.79. What is the ratio of the Emissions (in thousand metric tons of CO2 equivalent) of 1990 in Upper middle income to that in World?
Your answer should be very brief. 0.12. What is the ratio of the Emissions (in thousand metric tons of CO2 equivalent) in 2000 in Upper middle income to that in World?
Make the answer very short. 0.15. What is the ratio of the Emissions (in thousand metric tons of CO2 equivalent) of 2005 in Upper middle income to that in World?
Your response must be concise. 0.29. What is the ratio of the Emissions (in thousand metric tons of CO2 equivalent) in 2008 in Upper middle income to that in World?
Ensure brevity in your answer.  0.29. What is the ratio of the Emissions (in thousand metric tons of CO2 equivalent) of 1990 in Upper middle income to that in Algeria?
Give a very brief answer. 113.09. What is the ratio of the Emissions (in thousand metric tons of CO2 equivalent) of 2000 in Upper middle income to that in Algeria?
Offer a very short reply. 210.49. What is the ratio of the Emissions (in thousand metric tons of CO2 equivalent) of 2005 in Upper middle income to that in Algeria?
Offer a terse response. 458.83. What is the ratio of the Emissions (in thousand metric tons of CO2 equivalent) of 2008 in Upper middle income to that in Algeria?
Your answer should be compact. 420.19. What is the ratio of the Emissions (in thousand metric tons of CO2 equivalent) of 1990 in World to that in Algeria?
Provide a succinct answer. 936.6. What is the ratio of the Emissions (in thousand metric tons of CO2 equivalent) of 2000 in World to that in Algeria?
Make the answer very short. 1373.76. What is the ratio of the Emissions (in thousand metric tons of CO2 equivalent) of 2005 in World to that in Algeria?
Provide a short and direct response. 1557.54. What is the ratio of the Emissions (in thousand metric tons of CO2 equivalent) of 2008 in World to that in Algeria?
Your answer should be very brief. 1472.53. What is the difference between the highest and the second highest Emissions (in thousand metric tons of CO2 equivalent) of 1990?
Your response must be concise. 9.19e+04. What is the difference between the highest and the second highest Emissions (in thousand metric tons of CO2 equivalent) in 2000?
Make the answer very short. 1.56e+05. What is the difference between the highest and the second highest Emissions (in thousand metric tons of CO2 equivalent) of 2005?
Give a very brief answer. 3.17e+05. What is the difference between the highest and the second highest Emissions (in thousand metric tons of CO2 equivalent) of 2008?
Your answer should be very brief. 3.67e+05. What is the difference between the highest and the lowest Emissions (in thousand metric tons of CO2 equivalent) in 1990?
Your answer should be very brief. 3.05e+05. What is the difference between the highest and the lowest Emissions (in thousand metric tons of CO2 equivalent) of 2000?
Offer a very short reply. 5.11e+05. What is the difference between the highest and the lowest Emissions (in thousand metric tons of CO2 equivalent) in 2005?
Keep it short and to the point. 7.59e+05. What is the difference between the highest and the lowest Emissions (in thousand metric tons of CO2 equivalent) of 2008?
Provide a short and direct response. 9.03e+05. 